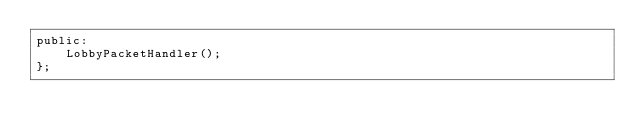Convert code to text. <code><loc_0><loc_0><loc_500><loc_500><_C_>public:
	LobbyPacketHandler();
};</code> 